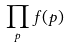Convert formula to latex. <formula><loc_0><loc_0><loc_500><loc_500>\prod _ { p } f ( p )</formula> 